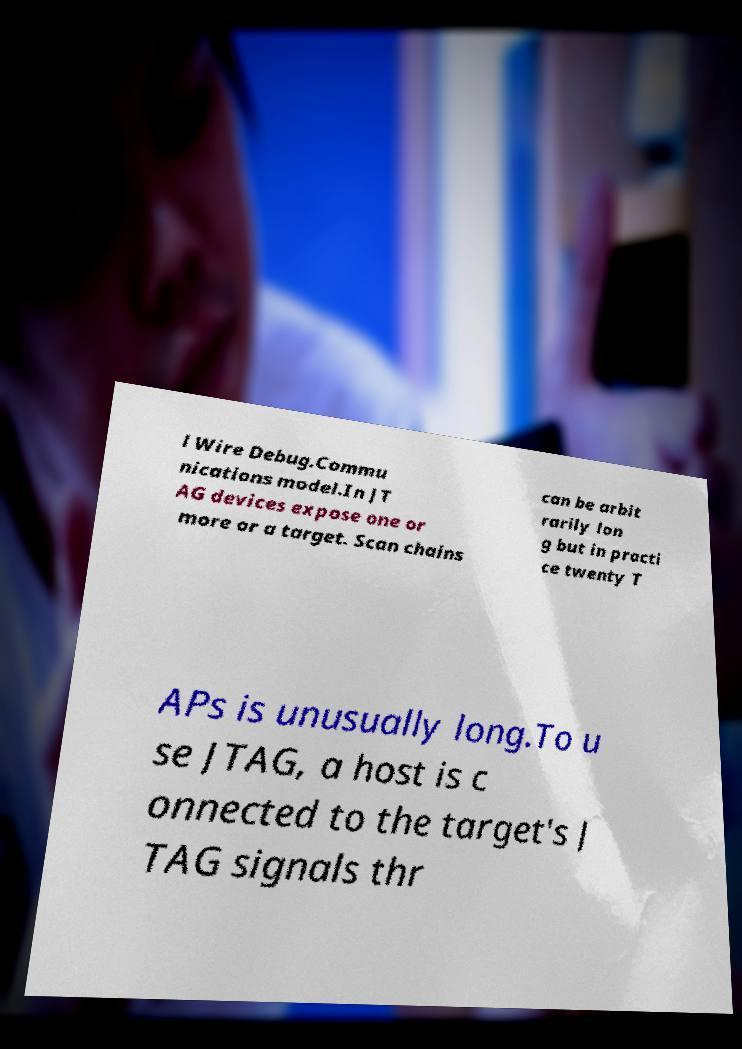Please identify and transcribe the text found in this image. l Wire Debug.Commu nications model.In JT AG devices expose one or more or a target. Scan chains can be arbit rarily lon g but in practi ce twenty T APs is unusually long.To u se JTAG, a host is c onnected to the target's J TAG signals thr 